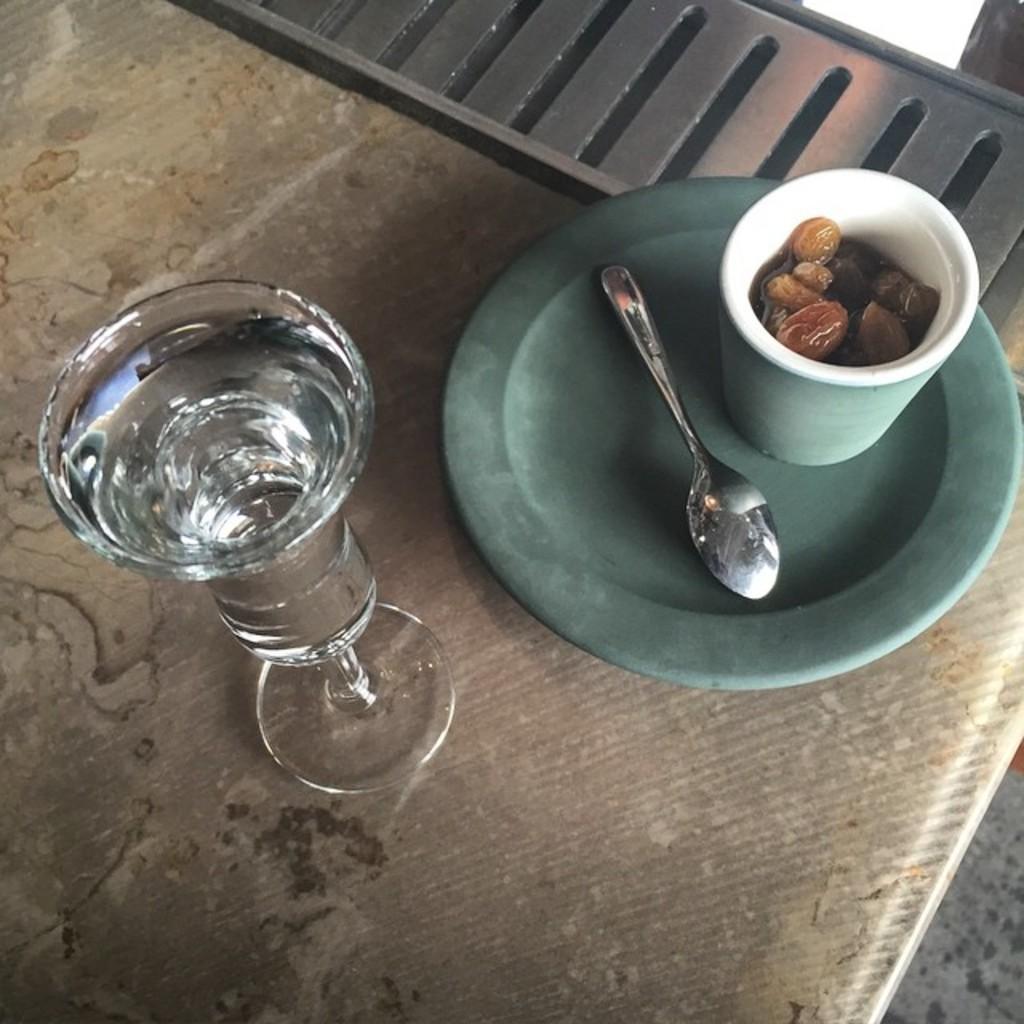Please provide a concise description of this image. In this image i can see a glass,spoon and dry fruits in a glass. 